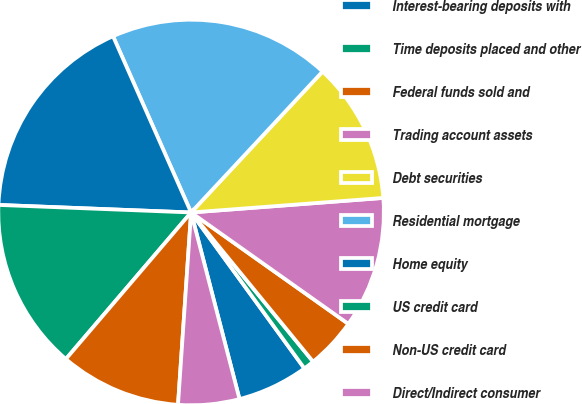Convert chart to OTSL. <chart><loc_0><loc_0><loc_500><loc_500><pie_chart><fcel>Interest-bearing deposits with<fcel>Time deposits placed and other<fcel>Federal funds sold and<fcel>Trading account assets<fcel>Debt securities<fcel>Residential mortgage<fcel>Home equity<fcel>US credit card<fcel>Non-US credit card<fcel>Direct/Indirect consumer<nl><fcel>5.96%<fcel>0.91%<fcel>4.28%<fcel>11.01%<fcel>11.85%<fcel>18.58%<fcel>17.74%<fcel>14.37%<fcel>10.17%<fcel>5.12%<nl></chart> 